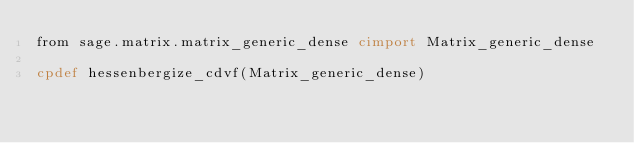Convert code to text. <code><loc_0><loc_0><loc_500><loc_500><_Cython_>from sage.matrix.matrix_generic_dense cimport Matrix_generic_dense

cpdef hessenbergize_cdvf(Matrix_generic_dense)
</code> 